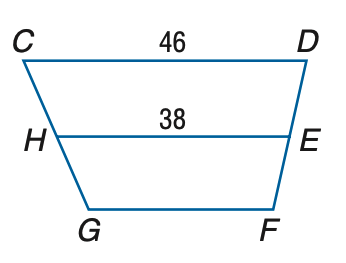Answer the mathemtical geometry problem and directly provide the correct option letter.
Question: Refer to trapezoid C D F G with median H E. Let Y Z be the median of H E F G. Find Y Z.
Choices: A: 34 B: 38 C: 42 D: 46 A 